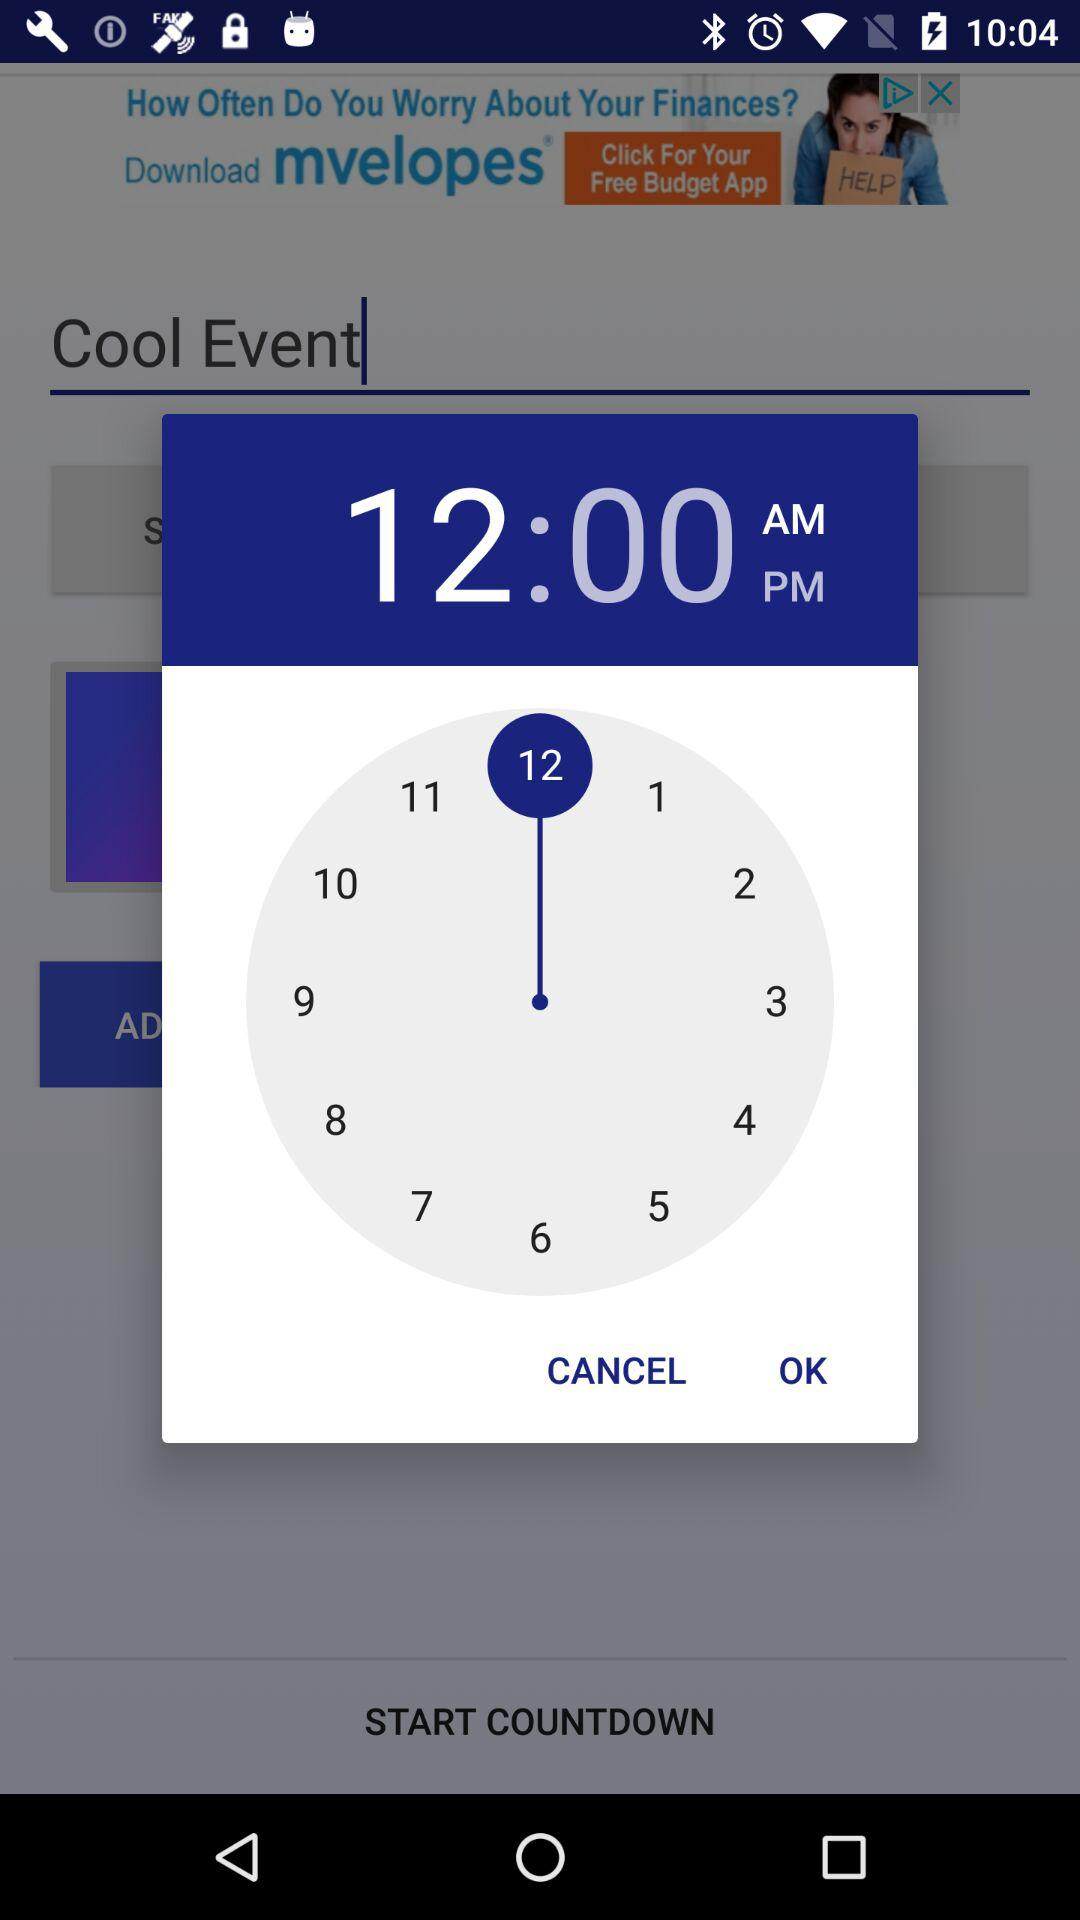What time is the alarm set to? The alarm is set to 12:00 AM. 